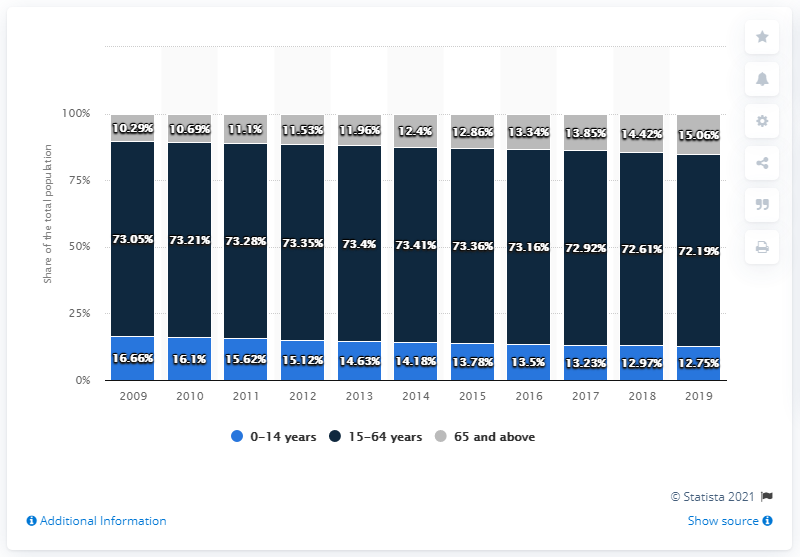Highlight a few significant elements in this photo. The age group of 15-64 years has the highest number of people consistently over the years. In 2009, there was the greatest difference between the population aged 65 and above and the population aged 0-14. 